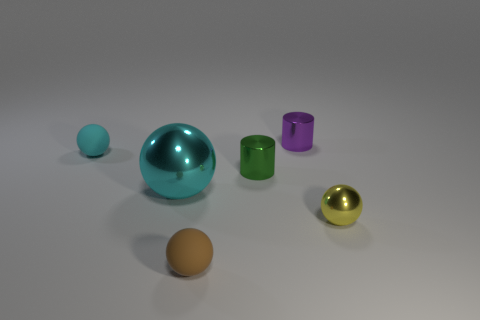Is there anything else that has the same size as the cyan metal object?
Offer a terse response. No. What shape is the tiny thing that is the same color as the large object?
Provide a succinct answer. Sphere. Is the number of brown spheres greater than the number of brown metallic cylinders?
Offer a very short reply. Yes. Does the small purple metallic thing behind the small brown matte thing have the same shape as the cyan metallic object?
Offer a very short reply. No. How many shiny things are in front of the purple cylinder and to the right of the green cylinder?
Provide a short and direct response. 1. What number of other matte objects are the same shape as the cyan matte thing?
Your answer should be very brief. 1. What color is the tiny matte object that is left of the rubber object that is in front of the large cyan shiny sphere?
Your answer should be compact. Cyan. Is the shape of the small brown thing the same as the small matte object that is behind the brown matte sphere?
Offer a very short reply. Yes. What material is the ball that is right of the tiny matte thing in front of the cyan shiny sphere that is to the left of the brown matte object?
Your response must be concise. Metal. Are there any brown rubber spheres of the same size as the purple object?
Offer a very short reply. Yes. 